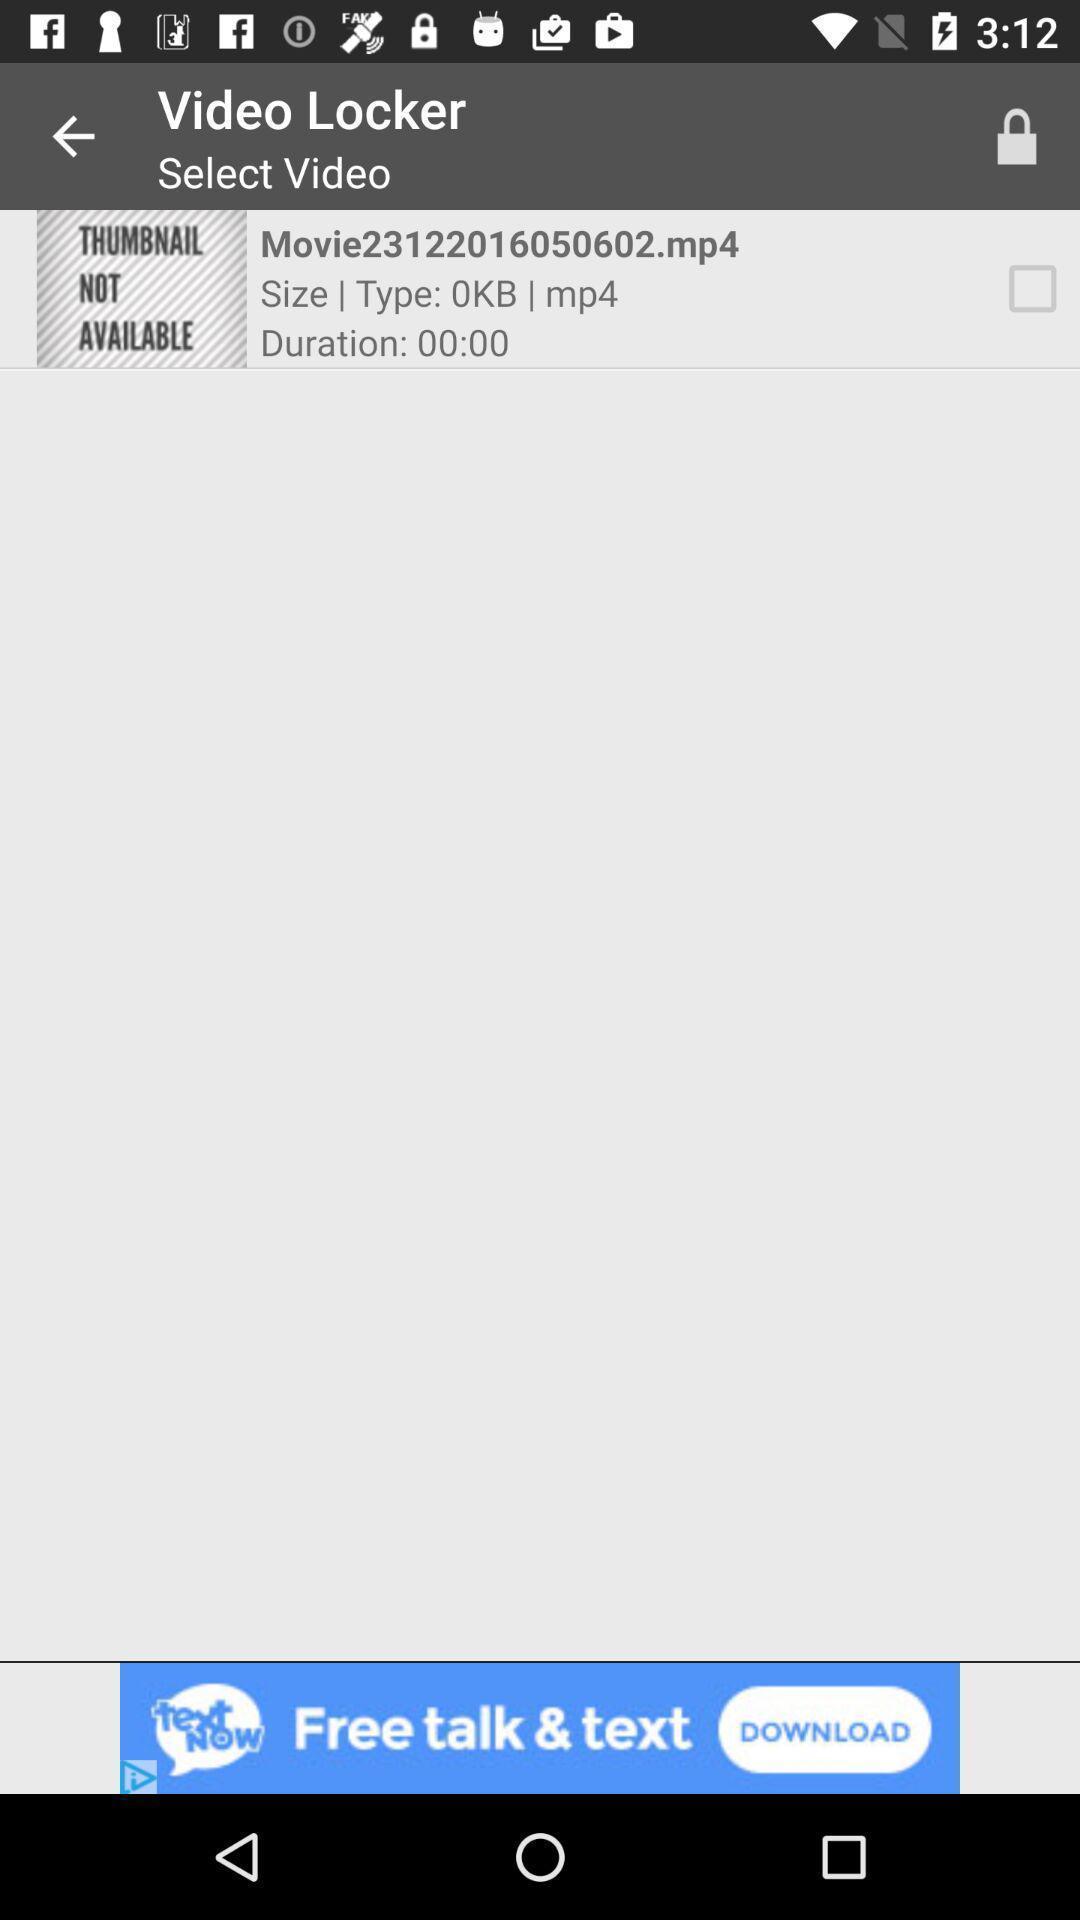Explain what's happening in this screen capture. Screen showing select video. 